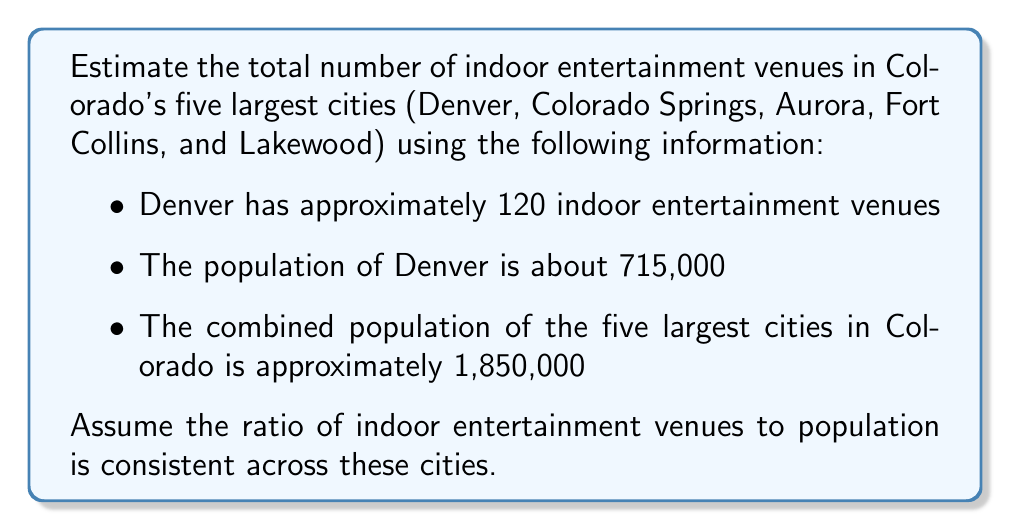Show me your answer to this math problem. Let's approach this step-by-step:

1. First, we need to find the ratio of indoor entertainment venues to population in Denver:
   $$\text{Ratio} = \frac{\text{Venues}}{\text{Population}} = \frac{120}{715,000} \approx 0.000168$$

2. Now, we assume this ratio is consistent across the five largest cities. To find the total number of venues, we can multiply this ratio by the total population of the five cities:
   $$\text{Total Venues} = \text{Ratio} \times \text{Total Population}$$

3. Substituting the values:
   $$\text{Total Venues} = 0.000168 \times 1,850,000$$

4. Calculating:
   $$\text{Total Venues} = 310.8$$

5. Since we can't have a fractional number of venues, we round to the nearest whole number:
   $$\text{Total Venues} \approx 311$$
Answer: 311 indoor entertainment venues 